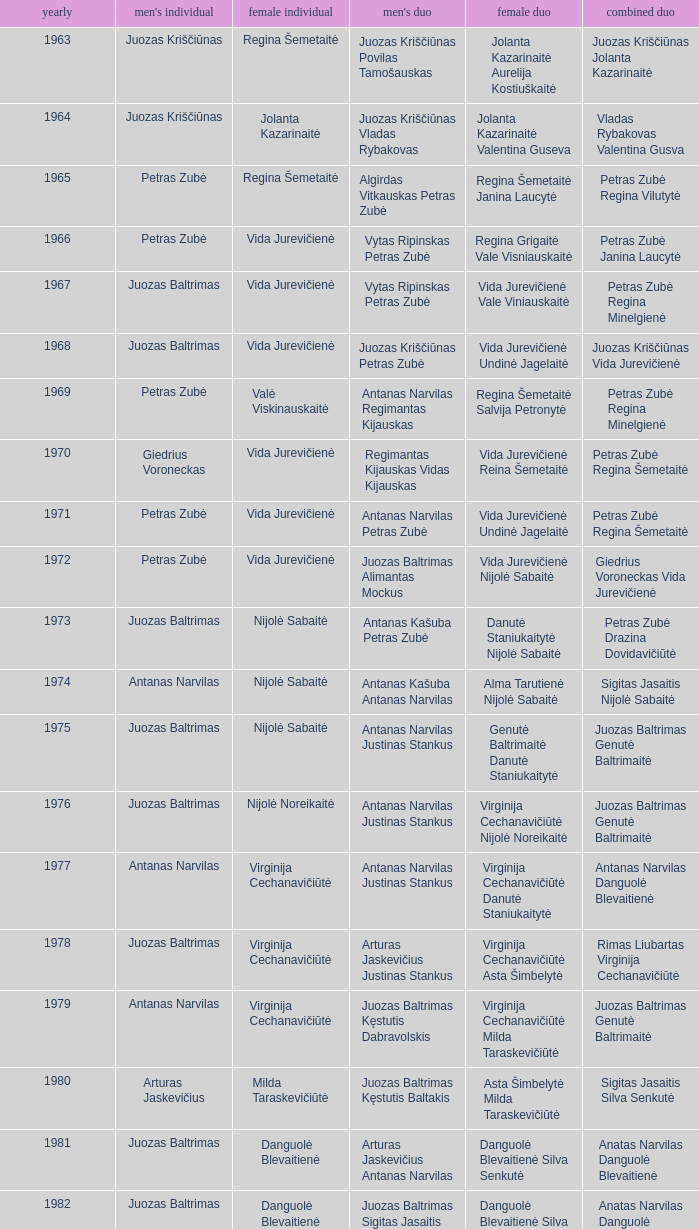What was the first year of the Lithuanian National Badminton Championships? 1963.0. 